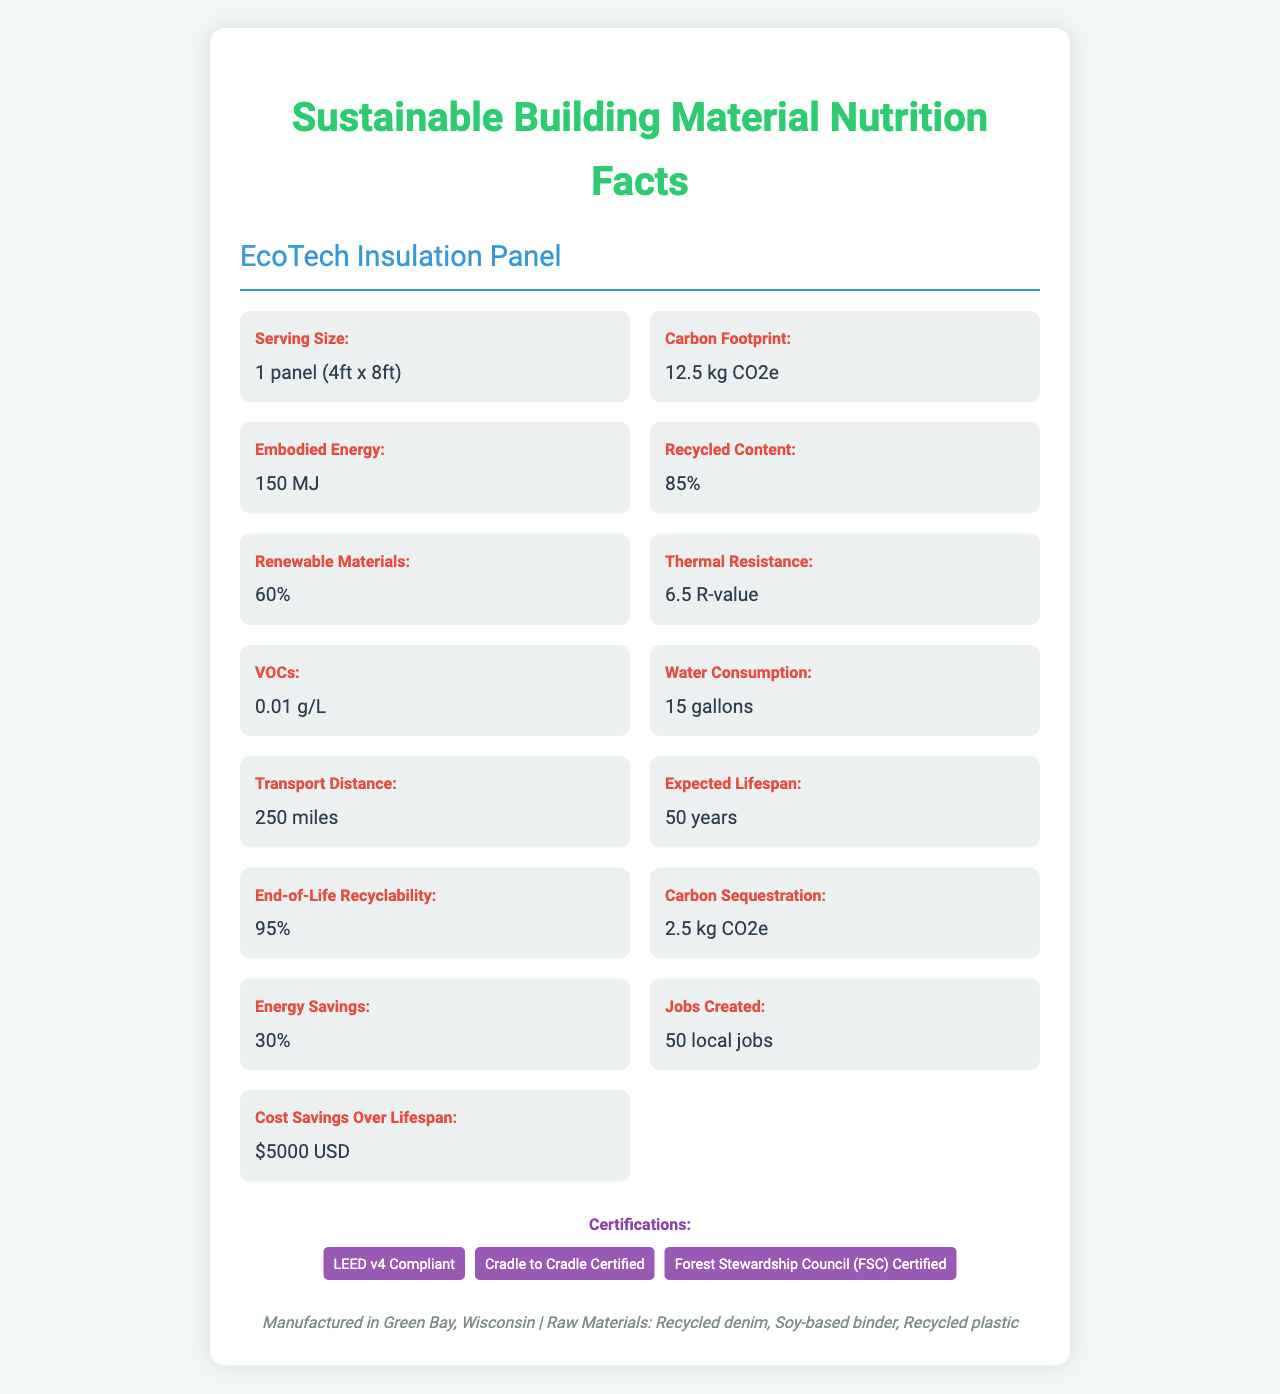what is the serving size of the EcoTech Insulation Panel? The document under the "Serving Size" section specifies it as 1 panel measuring 4ft x 8ft.
Answer: 1 panel (4ft x 8ft) What is the carbon footprint of this product? The document states under the "Carbon Footprint" section that the amount is 12.5 kg CO2e.
Answer: 12.5 kg CO2e What percentage of the EcoTech Insulation Panel is made from recycled content? The percentage is listed under the "Recycled Content" section as 85%.
Answer: 85% What is the expected lifespan of the EcoTech Insulation Panel? The "Expected Lifespan" section notes that the amount is 50 years.
Answer: 50 years What certifications does the EcoTech Insulation Panel have? The certifications are listed under the "Certifications" section of the document.
Answer: LEED v4 Compliant, Cradle to Cradle Certified, Forest Stewardship Council (FSC) Certified What raw materials are used in this product? A. Wood, Plastic, Glass B. Recycled denim, Soy-based binder, Recycled plastic C. Steel, Aluminum, Copper D. Bamboo, Cork, Wool The document under the "Raw Materials" section lists them as Recycled denim, Soy-based binder, and Recycled plastic.
Answer: B What is the percentage of renewable materials in the EcoTech Insulation Panel? A. 40% B. 50% C. 60% D. 70% The document lists 60% under the "Renewable Materials" section.
Answer: C Does the document specify the amount of volatile organic compounds (VOCs) present in the product? Yes/No The VOCs amount is listed as 0.01 g/L in the "VOCs" section.
Answer: Yes Summarize the main features and environmental benefits of the EcoTech Insulation Panel. The document highlights the environmental benefits, such as the carbon footprint of 12.5 kg CO2e, and 85% recycled content. It includes metrics like embodied energy (150 MJ), renewability (60%), and low VOCs (0.01 g/L). It provides energy savings (30%) and has a long lifespan (50 years), saving costs ($5000). Local job creation (50) and multiple certifications add to its benefits.
Answer: The EcoTech Insulation Panel is made from recycled materials with significant environmental benefits including low carbon footprint, high recycled content, renewable materials, low VOCs, water consumption, and end-of-life recyclability. It also provides energy savings, cost savings over its lifelong, and creates local jobs. It is certified by LEED v4, Cradle to Cradle, and FSC. Where is the EcoTech Insulation Panel manufactured? This information is given at the bottom of the document in the footer section.
Answer: Green Bay, Wisconsin How much water is consumed in the production of one EcoTech Insulation Panel? The document under "Water Consumption" states this amount.
Answer: 15 gallons What is the thermal resistance of the EcoTech Insulation Panel? The document mentions this under the "Thermal Resistance" section.
Answer: 6.5 R-value How far is the product typically transported? This figure is provided in the "Transport Distance" section.
Answer: 250 miles Can the exact production process details be determined from this document? The document does not detail the specific production processes, only the materials and certifications are listed.
Answer: Cannot be determined What is the embodied energy in the EcoTech Insulation Panel? This value is provided under the "Embodied Energy" section in the document.
Answer: 150 MJ 